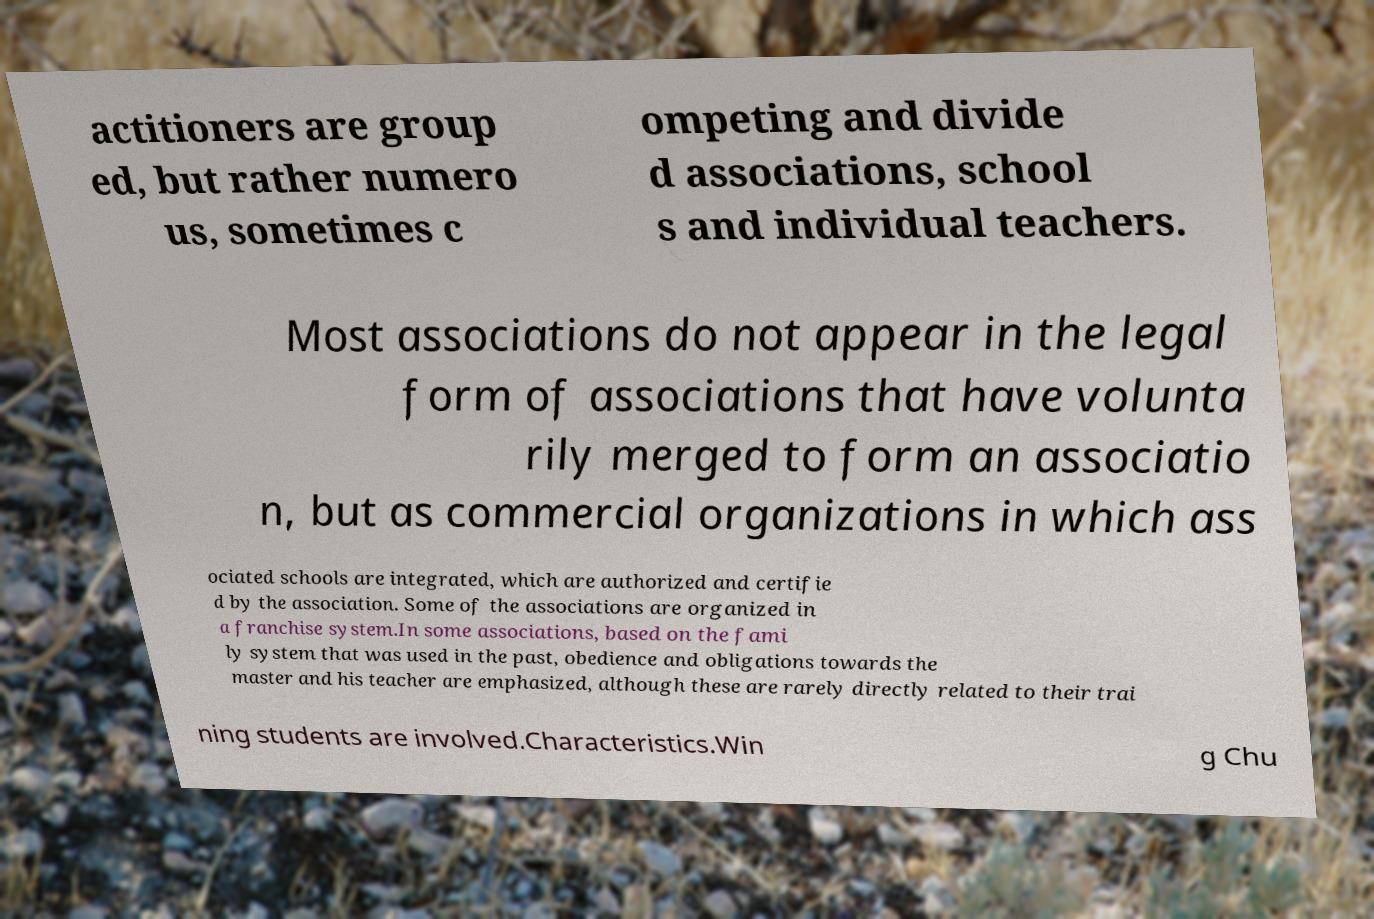There's text embedded in this image that I need extracted. Can you transcribe it verbatim? actitioners are group ed, but rather numero us, sometimes c ompeting and divide d associations, school s and individual teachers. Most associations do not appear in the legal form of associations that have volunta rily merged to form an associatio n, but as commercial organizations in which ass ociated schools are integrated, which are authorized and certifie d by the association. Some of the associations are organized in a franchise system.In some associations, based on the fami ly system that was used in the past, obedience and obligations towards the master and his teacher are emphasized, although these are rarely directly related to their trai ning students are involved.Characteristics.Win g Chu 